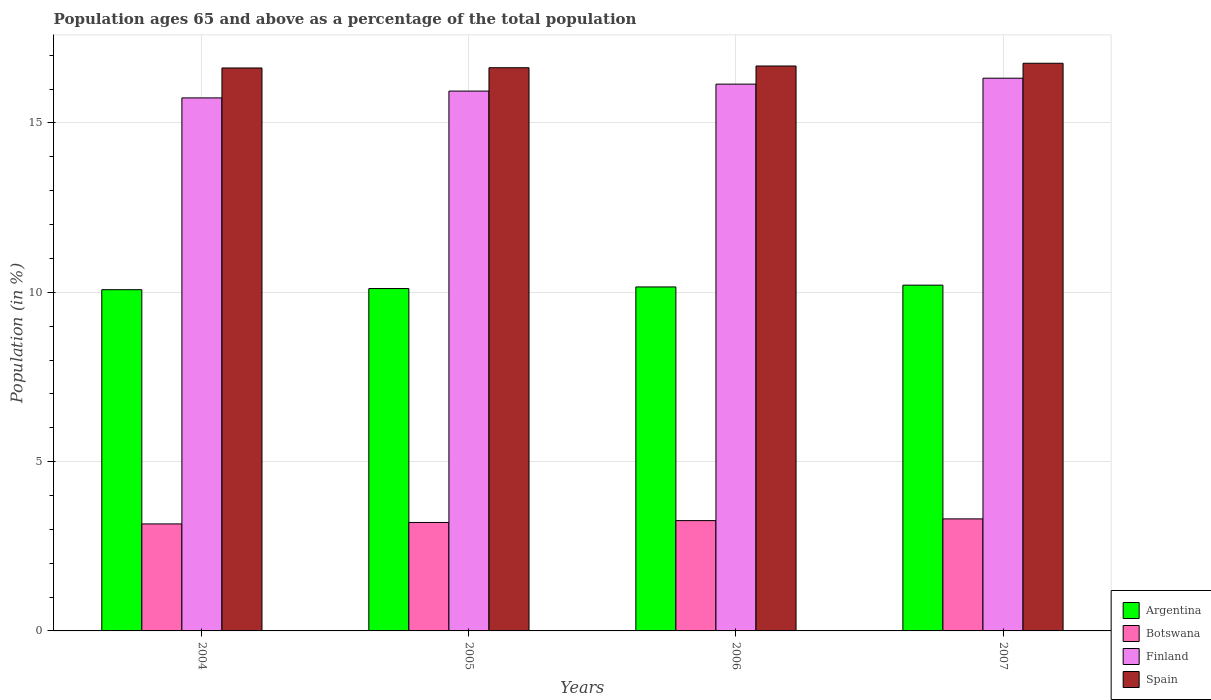How many different coloured bars are there?
Make the answer very short. 4. How many groups of bars are there?
Your answer should be compact. 4. Are the number of bars per tick equal to the number of legend labels?
Provide a short and direct response. Yes. What is the label of the 3rd group of bars from the left?
Provide a succinct answer. 2006. In how many cases, is the number of bars for a given year not equal to the number of legend labels?
Make the answer very short. 0. What is the percentage of the population ages 65 and above in Argentina in 2006?
Your answer should be very brief. 10.16. Across all years, what is the maximum percentage of the population ages 65 and above in Argentina?
Provide a succinct answer. 10.21. Across all years, what is the minimum percentage of the population ages 65 and above in Spain?
Provide a succinct answer. 16.62. What is the total percentage of the population ages 65 and above in Botswana in the graph?
Offer a terse response. 12.93. What is the difference between the percentage of the population ages 65 and above in Argentina in 2005 and that in 2006?
Give a very brief answer. -0.05. What is the difference between the percentage of the population ages 65 and above in Spain in 2007 and the percentage of the population ages 65 and above in Botswana in 2005?
Your response must be concise. 13.56. What is the average percentage of the population ages 65 and above in Argentina per year?
Offer a very short reply. 10.14. In the year 2004, what is the difference between the percentage of the population ages 65 and above in Finland and percentage of the population ages 65 and above in Spain?
Keep it short and to the point. -0.88. What is the ratio of the percentage of the population ages 65 and above in Argentina in 2006 to that in 2007?
Give a very brief answer. 0.99. What is the difference between the highest and the second highest percentage of the population ages 65 and above in Argentina?
Your answer should be very brief. 0.05. What is the difference between the highest and the lowest percentage of the population ages 65 and above in Spain?
Give a very brief answer. 0.14. Is it the case that in every year, the sum of the percentage of the population ages 65 and above in Spain and percentage of the population ages 65 and above in Botswana is greater than the sum of percentage of the population ages 65 and above in Finland and percentage of the population ages 65 and above in Argentina?
Offer a terse response. No. What does the 1st bar from the right in 2004 represents?
Your response must be concise. Spain. Are all the bars in the graph horizontal?
Your answer should be very brief. No. How many years are there in the graph?
Your answer should be compact. 4. How are the legend labels stacked?
Ensure brevity in your answer.  Vertical. What is the title of the graph?
Your answer should be compact. Population ages 65 and above as a percentage of the total population. What is the Population (in %) in Argentina in 2004?
Give a very brief answer. 10.08. What is the Population (in %) of Botswana in 2004?
Your answer should be very brief. 3.16. What is the Population (in %) of Finland in 2004?
Offer a very short reply. 15.74. What is the Population (in %) in Spain in 2004?
Your response must be concise. 16.62. What is the Population (in %) of Argentina in 2005?
Provide a short and direct response. 10.11. What is the Population (in %) in Botswana in 2005?
Make the answer very short. 3.2. What is the Population (in %) in Finland in 2005?
Ensure brevity in your answer.  15.94. What is the Population (in %) in Spain in 2005?
Your answer should be very brief. 16.63. What is the Population (in %) in Argentina in 2006?
Your answer should be very brief. 10.16. What is the Population (in %) of Botswana in 2006?
Offer a very short reply. 3.26. What is the Population (in %) in Finland in 2006?
Offer a terse response. 16.15. What is the Population (in %) in Spain in 2006?
Keep it short and to the point. 16.68. What is the Population (in %) of Argentina in 2007?
Give a very brief answer. 10.21. What is the Population (in %) of Botswana in 2007?
Make the answer very short. 3.31. What is the Population (in %) of Finland in 2007?
Offer a very short reply. 16.32. What is the Population (in %) in Spain in 2007?
Your answer should be compact. 16.76. Across all years, what is the maximum Population (in %) in Argentina?
Your response must be concise. 10.21. Across all years, what is the maximum Population (in %) in Botswana?
Offer a very short reply. 3.31. Across all years, what is the maximum Population (in %) in Finland?
Your answer should be very brief. 16.32. Across all years, what is the maximum Population (in %) in Spain?
Make the answer very short. 16.76. Across all years, what is the minimum Population (in %) in Argentina?
Make the answer very short. 10.08. Across all years, what is the minimum Population (in %) in Botswana?
Your answer should be compact. 3.16. Across all years, what is the minimum Population (in %) of Finland?
Ensure brevity in your answer.  15.74. Across all years, what is the minimum Population (in %) in Spain?
Provide a succinct answer. 16.62. What is the total Population (in %) in Argentina in the graph?
Offer a terse response. 40.56. What is the total Population (in %) in Botswana in the graph?
Provide a short and direct response. 12.93. What is the total Population (in %) in Finland in the graph?
Keep it short and to the point. 64.15. What is the total Population (in %) of Spain in the graph?
Provide a succinct answer. 66.7. What is the difference between the Population (in %) in Argentina in 2004 and that in 2005?
Your response must be concise. -0.03. What is the difference between the Population (in %) of Botswana in 2004 and that in 2005?
Offer a very short reply. -0.04. What is the difference between the Population (in %) of Finland in 2004 and that in 2005?
Provide a succinct answer. -0.2. What is the difference between the Population (in %) in Spain in 2004 and that in 2005?
Provide a short and direct response. -0.01. What is the difference between the Population (in %) in Argentina in 2004 and that in 2006?
Keep it short and to the point. -0.08. What is the difference between the Population (in %) of Botswana in 2004 and that in 2006?
Keep it short and to the point. -0.1. What is the difference between the Population (in %) of Finland in 2004 and that in 2006?
Keep it short and to the point. -0.41. What is the difference between the Population (in %) of Spain in 2004 and that in 2006?
Provide a short and direct response. -0.06. What is the difference between the Population (in %) in Argentina in 2004 and that in 2007?
Provide a succinct answer. -0.13. What is the difference between the Population (in %) of Botswana in 2004 and that in 2007?
Offer a very short reply. -0.15. What is the difference between the Population (in %) in Finland in 2004 and that in 2007?
Your response must be concise. -0.58. What is the difference between the Population (in %) in Spain in 2004 and that in 2007?
Ensure brevity in your answer.  -0.14. What is the difference between the Population (in %) of Argentina in 2005 and that in 2006?
Offer a very short reply. -0.05. What is the difference between the Population (in %) of Botswana in 2005 and that in 2006?
Make the answer very short. -0.05. What is the difference between the Population (in %) in Finland in 2005 and that in 2006?
Provide a short and direct response. -0.21. What is the difference between the Population (in %) of Spain in 2005 and that in 2006?
Make the answer very short. -0.05. What is the difference between the Population (in %) in Argentina in 2005 and that in 2007?
Offer a very short reply. -0.1. What is the difference between the Population (in %) of Botswana in 2005 and that in 2007?
Your answer should be compact. -0.11. What is the difference between the Population (in %) in Finland in 2005 and that in 2007?
Make the answer very short. -0.38. What is the difference between the Population (in %) of Spain in 2005 and that in 2007?
Provide a succinct answer. -0.13. What is the difference between the Population (in %) of Argentina in 2006 and that in 2007?
Provide a short and direct response. -0.05. What is the difference between the Population (in %) of Botswana in 2006 and that in 2007?
Your answer should be very brief. -0.05. What is the difference between the Population (in %) of Finland in 2006 and that in 2007?
Your response must be concise. -0.18. What is the difference between the Population (in %) in Spain in 2006 and that in 2007?
Ensure brevity in your answer.  -0.08. What is the difference between the Population (in %) in Argentina in 2004 and the Population (in %) in Botswana in 2005?
Give a very brief answer. 6.87. What is the difference between the Population (in %) in Argentina in 2004 and the Population (in %) in Finland in 2005?
Offer a terse response. -5.87. What is the difference between the Population (in %) in Argentina in 2004 and the Population (in %) in Spain in 2005?
Provide a succinct answer. -6.55. What is the difference between the Population (in %) of Botswana in 2004 and the Population (in %) of Finland in 2005?
Make the answer very short. -12.78. What is the difference between the Population (in %) in Botswana in 2004 and the Population (in %) in Spain in 2005?
Ensure brevity in your answer.  -13.47. What is the difference between the Population (in %) of Finland in 2004 and the Population (in %) of Spain in 2005?
Provide a short and direct response. -0.89. What is the difference between the Population (in %) of Argentina in 2004 and the Population (in %) of Botswana in 2006?
Give a very brief answer. 6.82. What is the difference between the Population (in %) in Argentina in 2004 and the Population (in %) in Finland in 2006?
Make the answer very short. -6.07. What is the difference between the Population (in %) of Argentina in 2004 and the Population (in %) of Spain in 2006?
Keep it short and to the point. -6.61. What is the difference between the Population (in %) in Botswana in 2004 and the Population (in %) in Finland in 2006?
Your response must be concise. -12.99. What is the difference between the Population (in %) of Botswana in 2004 and the Population (in %) of Spain in 2006?
Offer a very short reply. -13.52. What is the difference between the Population (in %) of Finland in 2004 and the Population (in %) of Spain in 2006?
Your response must be concise. -0.94. What is the difference between the Population (in %) in Argentina in 2004 and the Population (in %) in Botswana in 2007?
Offer a terse response. 6.77. What is the difference between the Population (in %) of Argentina in 2004 and the Population (in %) of Finland in 2007?
Ensure brevity in your answer.  -6.25. What is the difference between the Population (in %) in Argentina in 2004 and the Population (in %) in Spain in 2007?
Provide a short and direct response. -6.69. What is the difference between the Population (in %) in Botswana in 2004 and the Population (in %) in Finland in 2007?
Give a very brief answer. -13.16. What is the difference between the Population (in %) in Botswana in 2004 and the Population (in %) in Spain in 2007?
Give a very brief answer. -13.6. What is the difference between the Population (in %) of Finland in 2004 and the Population (in %) of Spain in 2007?
Make the answer very short. -1.02. What is the difference between the Population (in %) in Argentina in 2005 and the Population (in %) in Botswana in 2006?
Give a very brief answer. 6.85. What is the difference between the Population (in %) in Argentina in 2005 and the Population (in %) in Finland in 2006?
Offer a very short reply. -6.04. What is the difference between the Population (in %) of Argentina in 2005 and the Population (in %) of Spain in 2006?
Ensure brevity in your answer.  -6.57. What is the difference between the Population (in %) of Botswana in 2005 and the Population (in %) of Finland in 2006?
Provide a short and direct response. -12.94. What is the difference between the Population (in %) of Botswana in 2005 and the Population (in %) of Spain in 2006?
Provide a short and direct response. -13.48. What is the difference between the Population (in %) of Finland in 2005 and the Population (in %) of Spain in 2006?
Your answer should be very brief. -0.74. What is the difference between the Population (in %) of Argentina in 2005 and the Population (in %) of Botswana in 2007?
Your answer should be compact. 6.8. What is the difference between the Population (in %) of Argentina in 2005 and the Population (in %) of Finland in 2007?
Offer a terse response. -6.21. What is the difference between the Population (in %) of Argentina in 2005 and the Population (in %) of Spain in 2007?
Make the answer very short. -6.65. What is the difference between the Population (in %) of Botswana in 2005 and the Population (in %) of Finland in 2007?
Provide a short and direct response. -13.12. What is the difference between the Population (in %) of Botswana in 2005 and the Population (in %) of Spain in 2007?
Provide a short and direct response. -13.56. What is the difference between the Population (in %) of Finland in 2005 and the Population (in %) of Spain in 2007?
Keep it short and to the point. -0.82. What is the difference between the Population (in %) in Argentina in 2006 and the Population (in %) in Botswana in 2007?
Offer a very short reply. 6.85. What is the difference between the Population (in %) in Argentina in 2006 and the Population (in %) in Finland in 2007?
Your answer should be compact. -6.16. What is the difference between the Population (in %) in Argentina in 2006 and the Population (in %) in Spain in 2007?
Offer a very short reply. -6.61. What is the difference between the Population (in %) of Botswana in 2006 and the Population (in %) of Finland in 2007?
Ensure brevity in your answer.  -13.06. What is the difference between the Population (in %) of Botswana in 2006 and the Population (in %) of Spain in 2007?
Make the answer very short. -13.51. What is the difference between the Population (in %) of Finland in 2006 and the Population (in %) of Spain in 2007?
Give a very brief answer. -0.62. What is the average Population (in %) in Argentina per year?
Your response must be concise. 10.14. What is the average Population (in %) in Botswana per year?
Offer a very short reply. 3.23. What is the average Population (in %) of Finland per year?
Give a very brief answer. 16.04. What is the average Population (in %) of Spain per year?
Keep it short and to the point. 16.68. In the year 2004, what is the difference between the Population (in %) of Argentina and Population (in %) of Botswana?
Your answer should be very brief. 6.92. In the year 2004, what is the difference between the Population (in %) of Argentina and Population (in %) of Finland?
Make the answer very short. -5.66. In the year 2004, what is the difference between the Population (in %) of Argentina and Population (in %) of Spain?
Ensure brevity in your answer.  -6.55. In the year 2004, what is the difference between the Population (in %) of Botswana and Population (in %) of Finland?
Provide a short and direct response. -12.58. In the year 2004, what is the difference between the Population (in %) in Botswana and Population (in %) in Spain?
Offer a terse response. -13.46. In the year 2004, what is the difference between the Population (in %) in Finland and Population (in %) in Spain?
Give a very brief answer. -0.88. In the year 2005, what is the difference between the Population (in %) of Argentina and Population (in %) of Botswana?
Keep it short and to the point. 6.91. In the year 2005, what is the difference between the Population (in %) of Argentina and Population (in %) of Finland?
Make the answer very short. -5.83. In the year 2005, what is the difference between the Population (in %) of Argentina and Population (in %) of Spain?
Give a very brief answer. -6.52. In the year 2005, what is the difference between the Population (in %) of Botswana and Population (in %) of Finland?
Give a very brief answer. -12.74. In the year 2005, what is the difference between the Population (in %) of Botswana and Population (in %) of Spain?
Provide a short and direct response. -13.43. In the year 2005, what is the difference between the Population (in %) in Finland and Population (in %) in Spain?
Provide a succinct answer. -0.69. In the year 2006, what is the difference between the Population (in %) in Argentina and Population (in %) in Botswana?
Offer a terse response. 6.9. In the year 2006, what is the difference between the Population (in %) in Argentina and Population (in %) in Finland?
Provide a short and direct response. -5.99. In the year 2006, what is the difference between the Population (in %) of Argentina and Population (in %) of Spain?
Your answer should be very brief. -6.52. In the year 2006, what is the difference between the Population (in %) of Botswana and Population (in %) of Finland?
Give a very brief answer. -12.89. In the year 2006, what is the difference between the Population (in %) in Botswana and Population (in %) in Spain?
Offer a very short reply. -13.42. In the year 2006, what is the difference between the Population (in %) in Finland and Population (in %) in Spain?
Provide a short and direct response. -0.54. In the year 2007, what is the difference between the Population (in %) in Argentina and Population (in %) in Botswana?
Your answer should be very brief. 6.9. In the year 2007, what is the difference between the Population (in %) in Argentina and Population (in %) in Finland?
Give a very brief answer. -6.11. In the year 2007, what is the difference between the Population (in %) in Argentina and Population (in %) in Spain?
Your response must be concise. -6.55. In the year 2007, what is the difference between the Population (in %) in Botswana and Population (in %) in Finland?
Provide a succinct answer. -13.01. In the year 2007, what is the difference between the Population (in %) of Botswana and Population (in %) of Spain?
Provide a succinct answer. -13.45. In the year 2007, what is the difference between the Population (in %) in Finland and Population (in %) in Spain?
Ensure brevity in your answer.  -0.44. What is the ratio of the Population (in %) in Argentina in 2004 to that in 2005?
Offer a terse response. 1. What is the ratio of the Population (in %) of Botswana in 2004 to that in 2005?
Your answer should be compact. 0.99. What is the ratio of the Population (in %) in Finland in 2004 to that in 2005?
Provide a short and direct response. 0.99. What is the ratio of the Population (in %) in Spain in 2004 to that in 2005?
Your response must be concise. 1. What is the ratio of the Population (in %) in Botswana in 2004 to that in 2006?
Offer a terse response. 0.97. What is the ratio of the Population (in %) of Finland in 2004 to that in 2006?
Your answer should be compact. 0.97. What is the ratio of the Population (in %) of Spain in 2004 to that in 2006?
Provide a short and direct response. 1. What is the ratio of the Population (in %) of Argentina in 2004 to that in 2007?
Give a very brief answer. 0.99. What is the ratio of the Population (in %) of Botswana in 2004 to that in 2007?
Provide a short and direct response. 0.96. What is the ratio of the Population (in %) in Finland in 2004 to that in 2007?
Your answer should be very brief. 0.96. What is the ratio of the Population (in %) in Spain in 2004 to that in 2007?
Provide a short and direct response. 0.99. What is the ratio of the Population (in %) in Argentina in 2005 to that in 2006?
Make the answer very short. 1. What is the ratio of the Population (in %) of Botswana in 2005 to that in 2006?
Make the answer very short. 0.98. What is the ratio of the Population (in %) in Finland in 2005 to that in 2006?
Keep it short and to the point. 0.99. What is the ratio of the Population (in %) of Argentina in 2005 to that in 2007?
Your answer should be very brief. 0.99. What is the ratio of the Population (in %) in Botswana in 2005 to that in 2007?
Your answer should be compact. 0.97. What is the ratio of the Population (in %) of Finland in 2005 to that in 2007?
Your answer should be very brief. 0.98. What is the ratio of the Population (in %) in Spain in 2005 to that in 2007?
Provide a short and direct response. 0.99. What is the ratio of the Population (in %) in Botswana in 2006 to that in 2007?
Your answer should be very brief. 0.98. What is the ratio of the Population (in %) in Finland in 2006 to that in 2007?
Offer a very short reply. 0.99. What is the difference between the highest and the second highest Population (in %) in Argentina?
Provide a succinct answer. 0.05. What is the difference between the highest and the second highest Population (in %) of Botswana?
Give a very brief answer. 0.05. What is the difference between the highest and the second highest Population (in %) in Finland?
Provide a short and direct response. 0.18. What is the difference between the highest and the second highest Population (in %) of Spain?
Make the answer very short. 0.08. What is the difference between the highest and the lowest Population (in %) in Argentina?
Your answer should be compact. 0.13. What is the difference between the highest and the lowest Population (in %) in Botswana?
Provide a short and direct response. 0.15. What is the difference between the highest and the lowest Population (in %) of Finland?
Your response must be concise. 0.58. What is the difference between the highest and the lowest Population (in %) of Spain?
Your response must be concise. 0.14. 